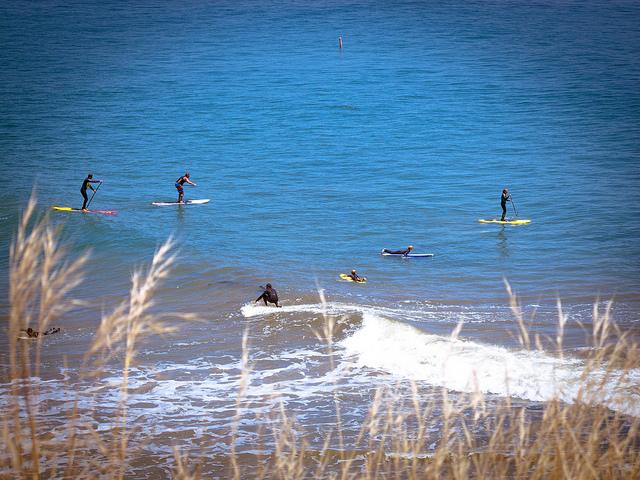What are the people wearing?
Concise answer only. Wetsuits. Is the ocean smooth?
Quick response, please. Yes. How many people are in the ocean?
Give a very brief answer. 7. 